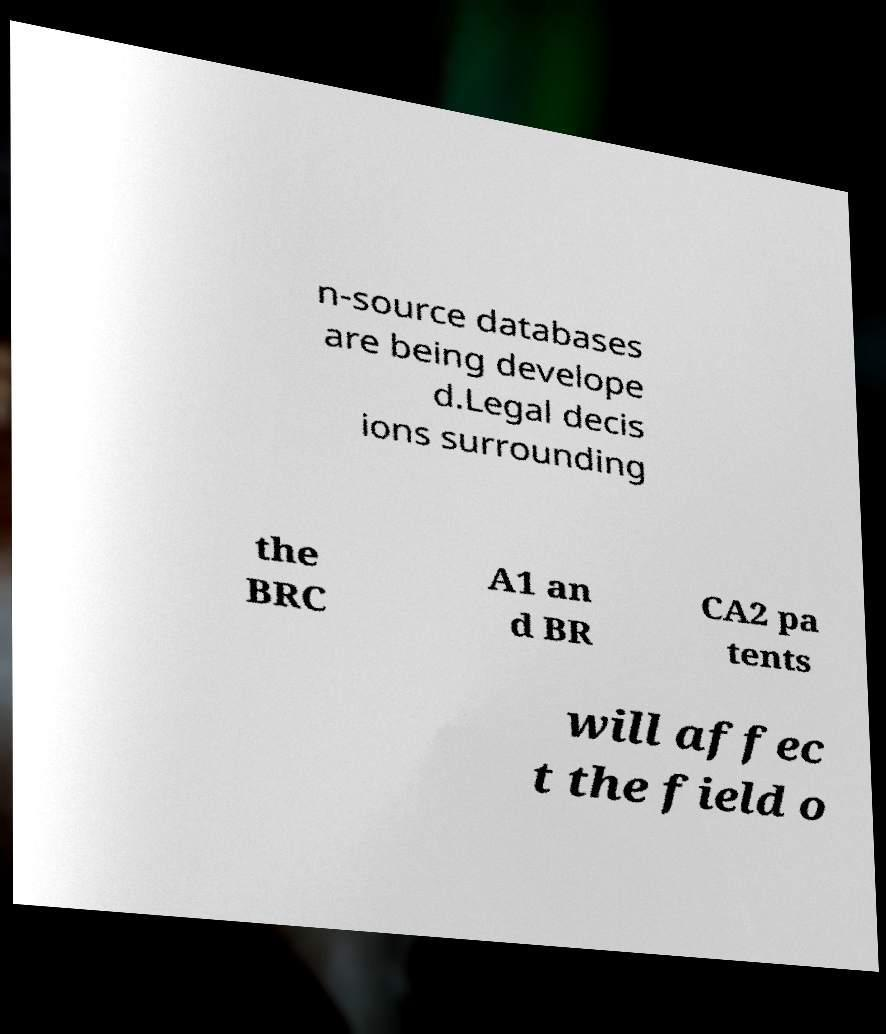Please identify and transcribe the text found in this image. n-source databases are being develope d.Legal decis ions surrounding the BRC A1 an d BR CA2 pa tents will affec t the field o 